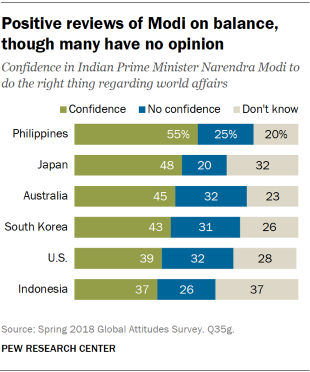Give some essential details in this illustration. Of the green bars with a value below 40, there are only two. In Japan, the value of the gray bar is 32. 